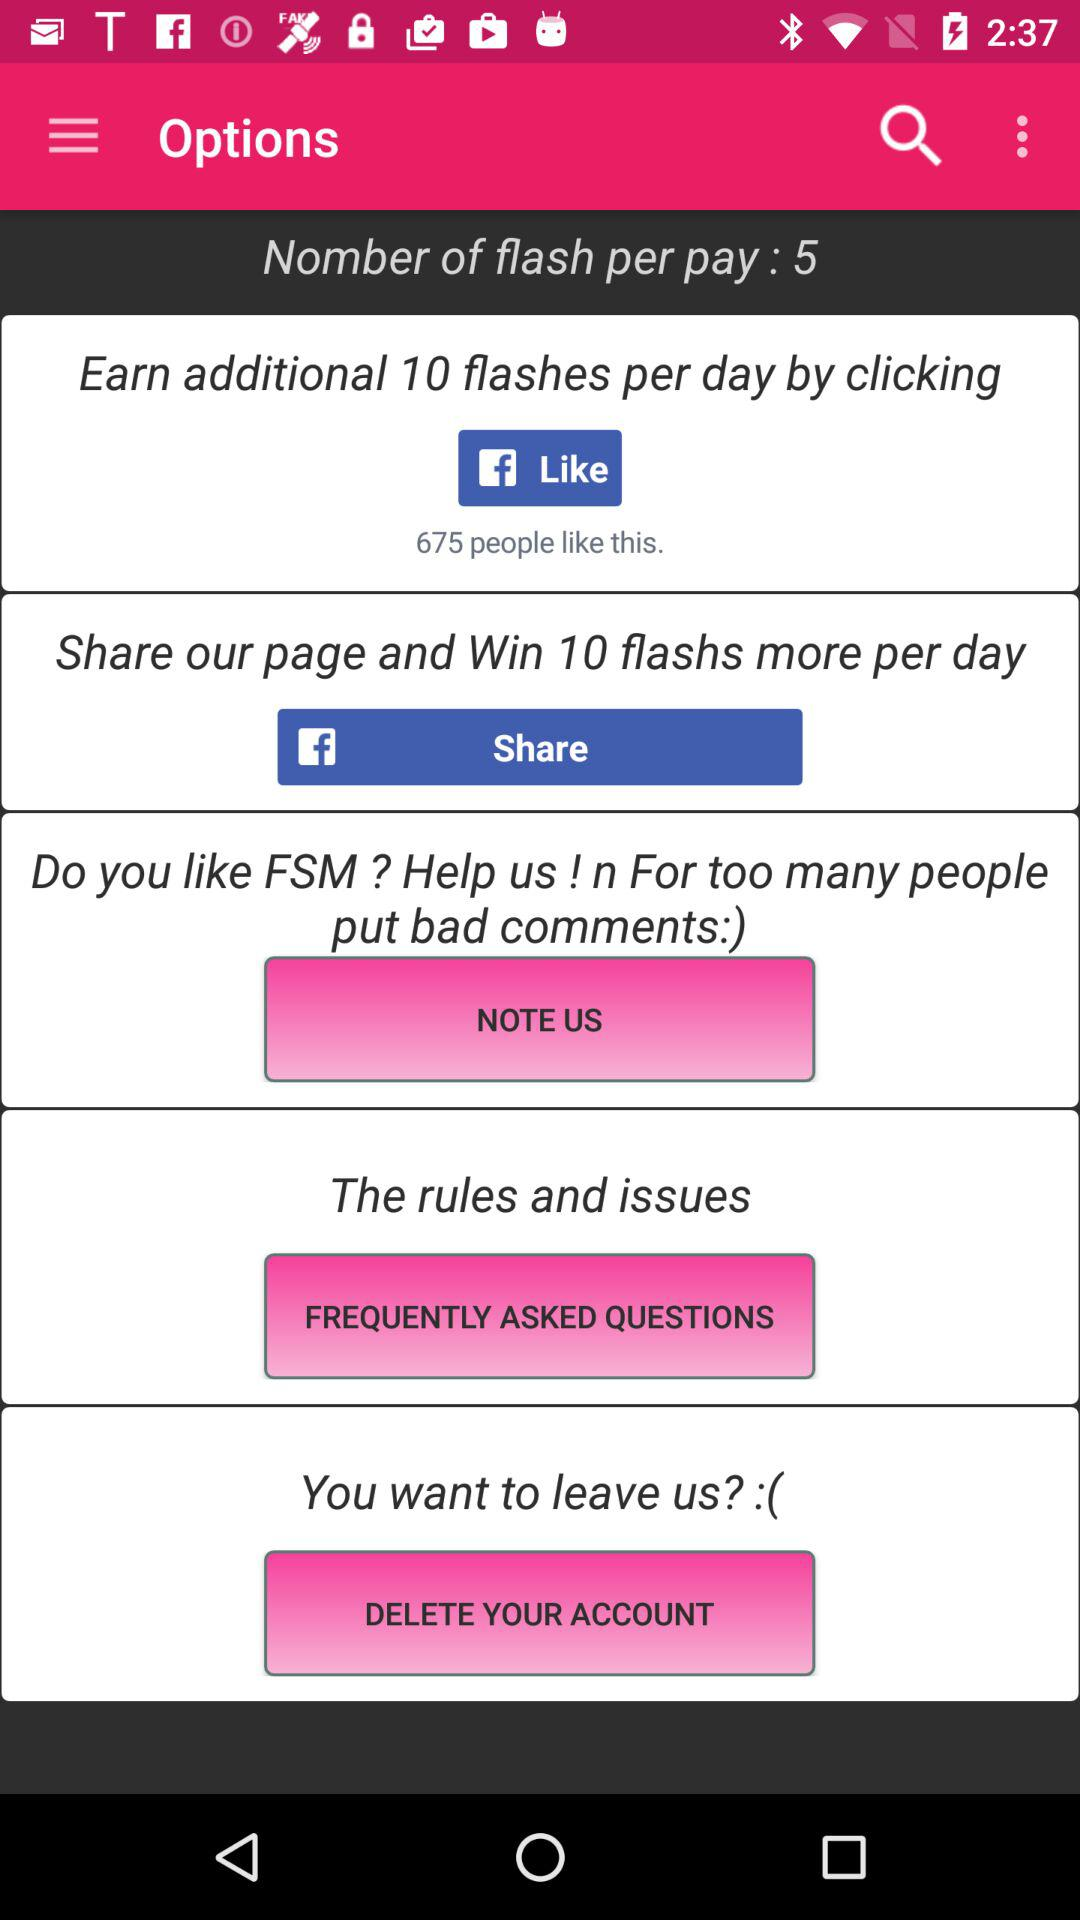How many additional flashes are earned per day by clicking? The additional flashes earned per day by clicking are 10. 